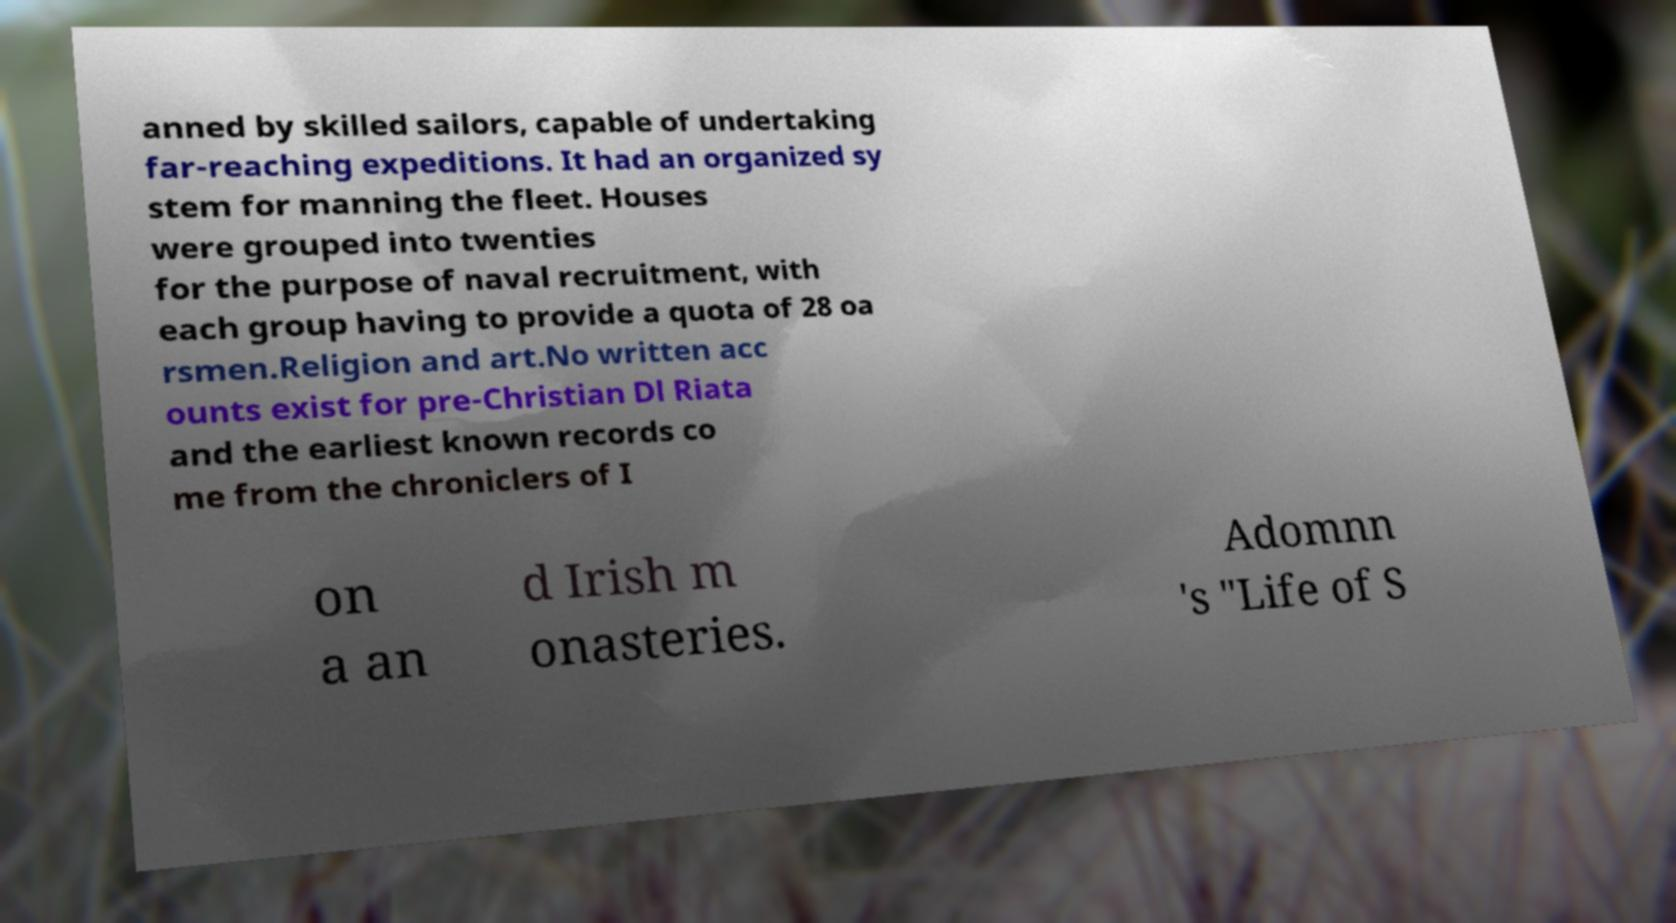Can you read and provide the text displayed in the image?This photo seems to have some interesting text. Can you extract and type it out for me? anned by skilled sailors, capable of undertaking far-reaching expeditions. It had an organized sy stem for manning the fleet. Houses were grouped into twenties for the purpose of naval recruitment, with each group having to provide a quota of 28 oa rsmen.Religion and art.No written acc ounts exist for pre-Christian Dl Riata and the earliest known records co me from the chroniclers of I on a an d Irish m onasteries. Adomnn 's "Life of S 